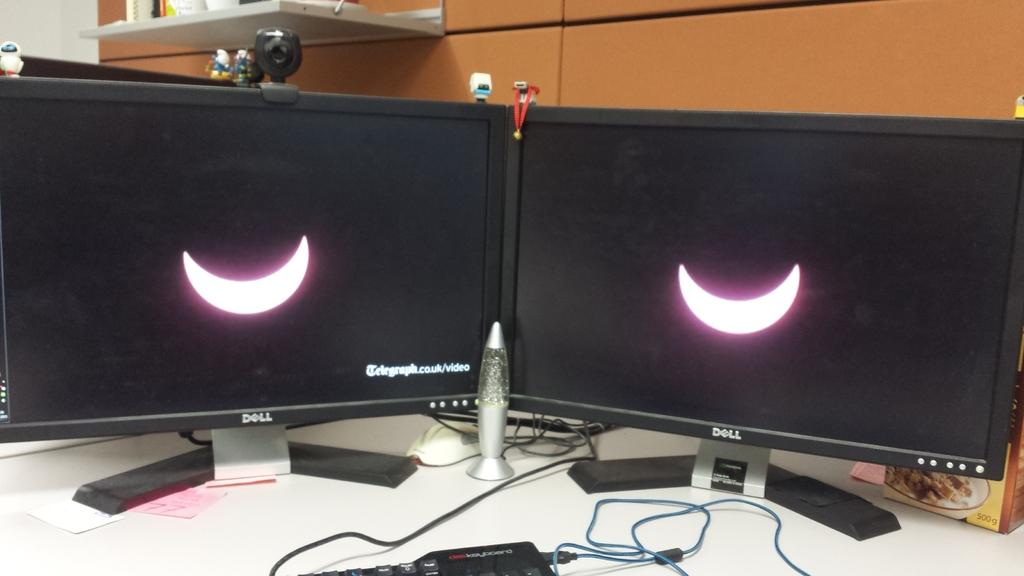<image>
Offer a succinct explanation of the picture presented. A Dell monitor show an image of a moon. 